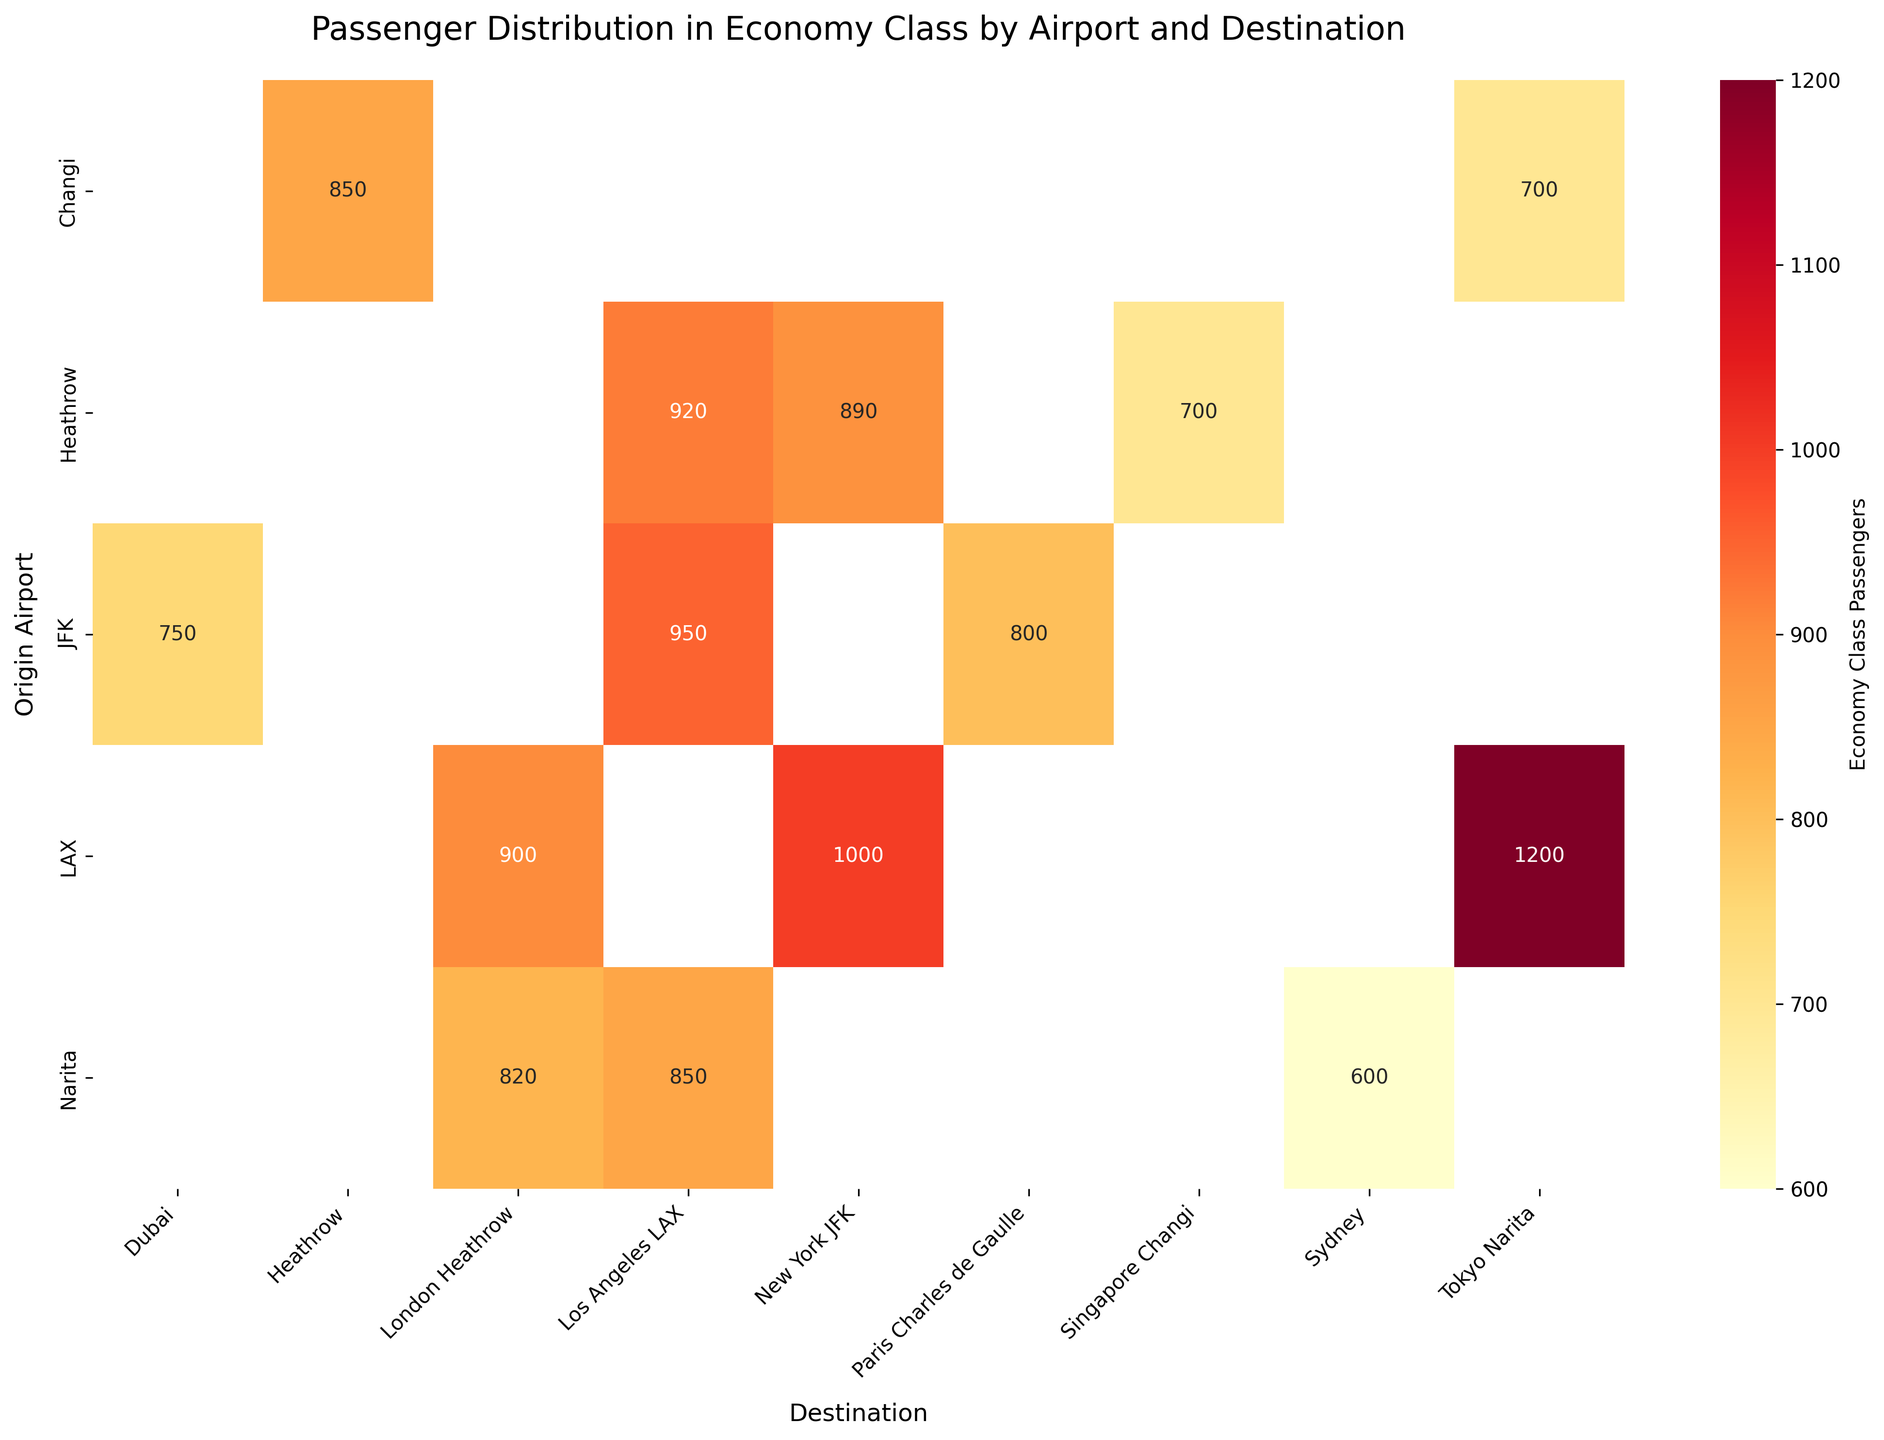What's the title of the plot? The plot's title can be found at the top of the figure. It usually describes the main point of the figure summarizing the data or the analysis.
Answer: Passenger Distribution in Economy Class by Airport and Destination How many origin airports are shown in the heatmap? The number of origin airports can be identified by counting the unique labels along the y-axis.
Answer: 5 Which destination from LAX has the highest number of economy class passengers? By inspecting the heatmap cells corresponding to LAX across different destinations and comparing their values, we identify the destination with the highest value.
Answer: Tokyo Narita What is the total number of economy class passengers flying from JFK? To find the total number of economy class passengers flying from JFK, sum up the values in the heatmap cells in the row labeled JFK. This involves adding up the numbers 950, 800, and 750.
Answer: 2500 Among LAX and Heathrow, which airport has more economy class passengers flying to New York JFK? Compare the values in the heatmap cells at the intersection of LAX and Heathrow with the destination New York JFK.
Answer: Heathrow Which destination has the least economy class passengers flying from Narita? By examining the heatmap cells in the Narita row and identifying the smallest value, we find the answer.
Answer: Sydney What's the average number of economy class passengers from Changi to its three destinations? To find the average, sum up the values for the three destinations (850, 700) corresponding to Changi and then divide by the number of destinations (2). (850 + 700) / 2 = 775.
Answer: 775 Which origin airport has the highest variability in economy class passengers across destinations? To determine the variability, look at the range of values (difference between max and min) for each airport's row in the heatmap. Calculate the differences and determine the highest range. For instance, LAX has values 1000, 900, 1200 giving a range of 300, while other airports have lower ranges.
Answer: LAX 